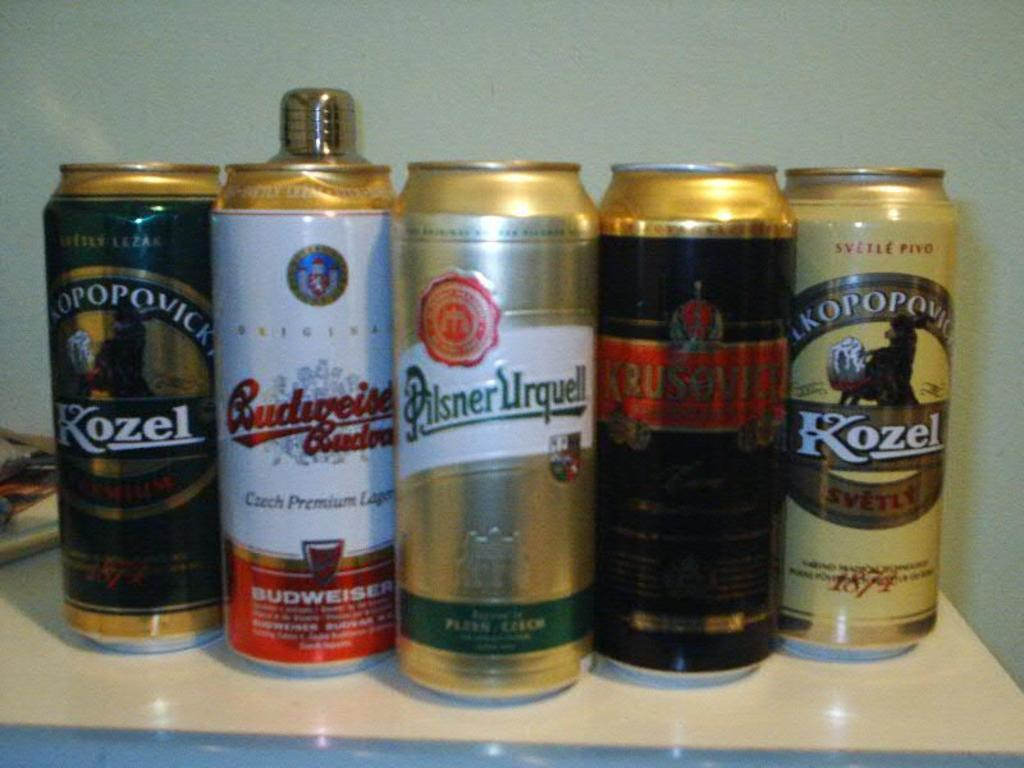<image>
Render a clear and concise summary of the photo. Two of out the five beers featured are by Kozel. 